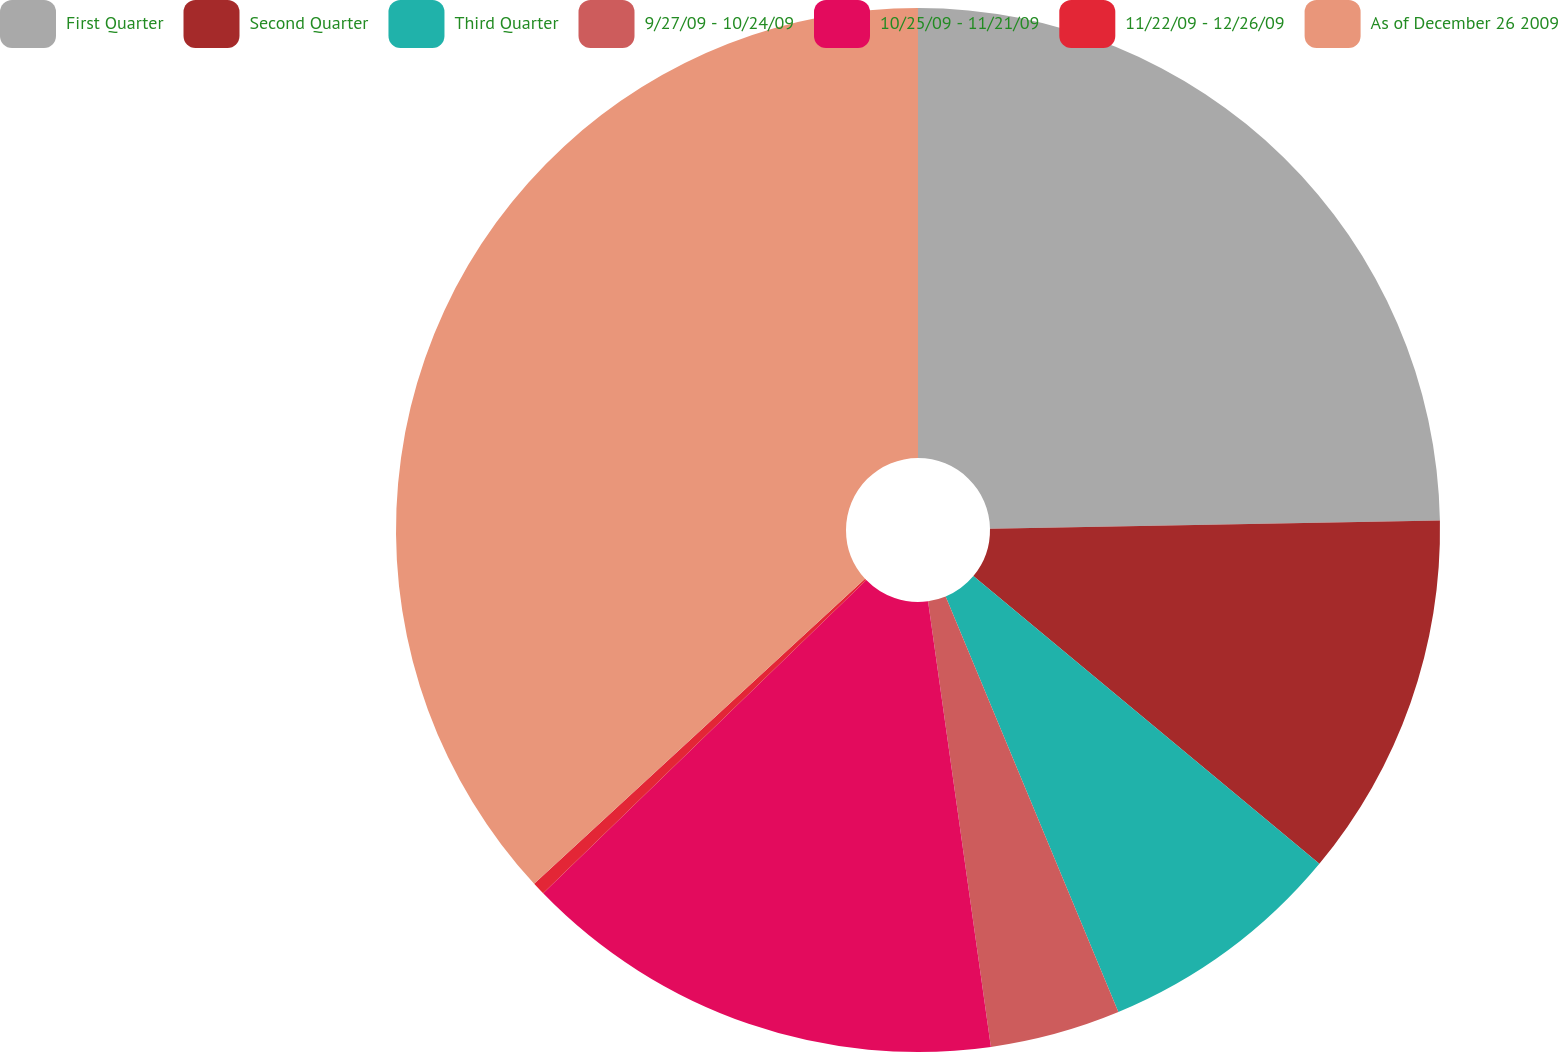Convert chart. <chart><loc_0><loc_0><loc_500><loc_500><pie_chart><fcel>First Quarter<fcel>Second Quarter<fcel>Third Quarter<fcel>9/27/09 - 10/24/09<fcel>10/25/09 - 11/21/09<fcel>11/22/09 - 12/26/09<fcel>As of December 26 2009<nl><fcel>24.71%<fcel>11.33%<fcel>7.69%<fcel>4.04%<fcel>14.98%<fcel>0.4%<fcel>36.85%<nl></chart> 